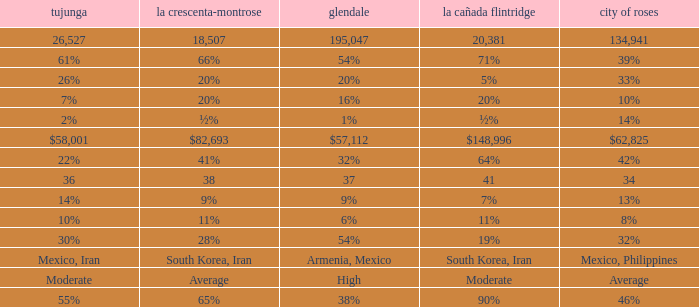Could you parse the entire table as a dict? {'header': ['tujunga', 'la crescenta-montrose', 'glendale', 'la cañada flintridge', 'city of roses'], 'rows': [['26,527', '18,507', '195,047', '20,381', '134,941'], ['61%', '66%', '54%', '71%', '39%'], ['26%', '20%', '20%', '5%', '33%'], ['7%', '20%', '16%', '20%', '10%'], ['2%', '½%', '1%', '½%', '14%'], ['$58,001', '$82,693', '$57,112', '$148,996', '$62,825'], ['22%', '41%', '32%', '64%', '42%'], ['36', '38', '37', '41', '34'], ['14%', '9%', '9%', '7%', '13%'], ['10%', '11%', '6%', '11%', '8%'], ['30%', '28%', '54%', '19%', '32%'], ['Mexico, Iran', 'South Korea, Iran', 'Armenia, Mexico', 'South Korea, Iran', 'Mexico, Philippines'], ['Moderate', 'Average', 'High', 'Moderate', 'Average'], ['55%', '65%', '38%', '90%', '46%']]} When La Crescenta-Montrose has 66%, what is Tujunga? 61%. 